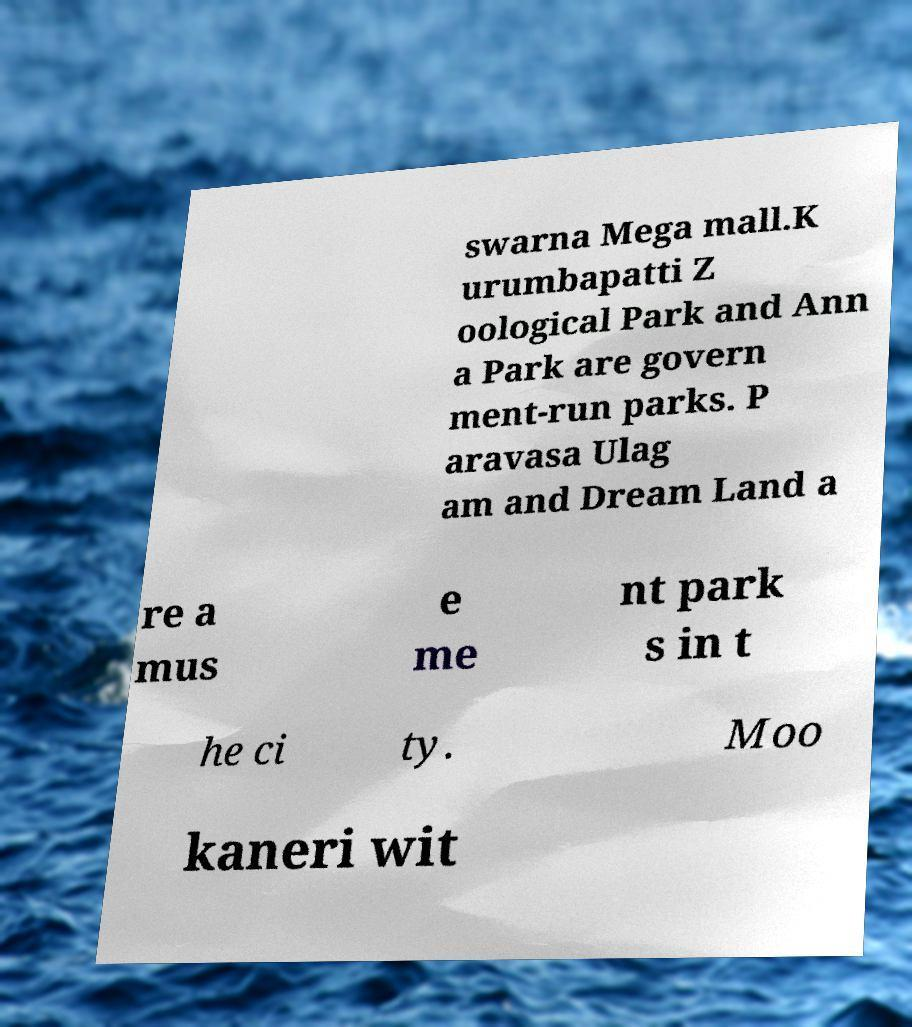What messages or text are displayed in this image? I need them in a readable, typed format. swarna Mega mall.K urumbapatti Z oological Park and Ann a Park are govern ment-run parks. P aravasa Ulag am and Dream Land a re a mus e me nt park s in t he ci ty. Moo kaneri wit 